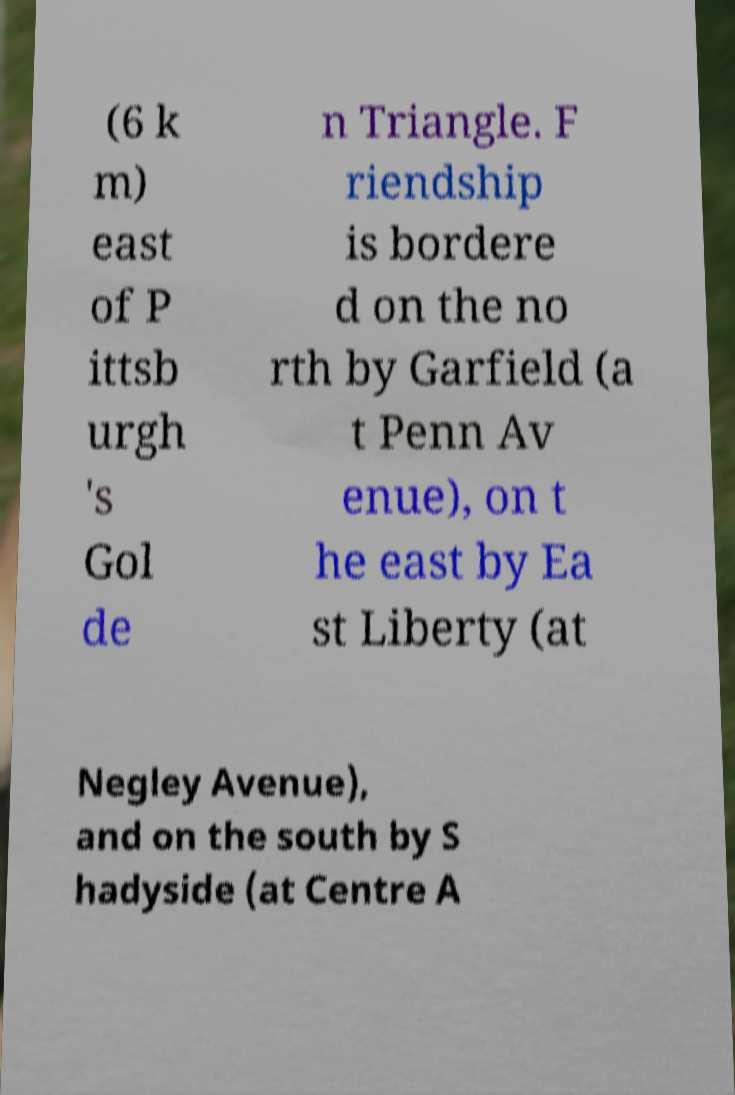Please read and relay the text visible in this image. What does it say? (6 k m) east of P ittsb urgh 's Gol de n Triangle. F riendship is bordere d on the no rth by Garfield (a t Penn Av enue), on t he east by Ea st Liberty (at Negley Avenue), and on the south by S hadyside (at Centre A 